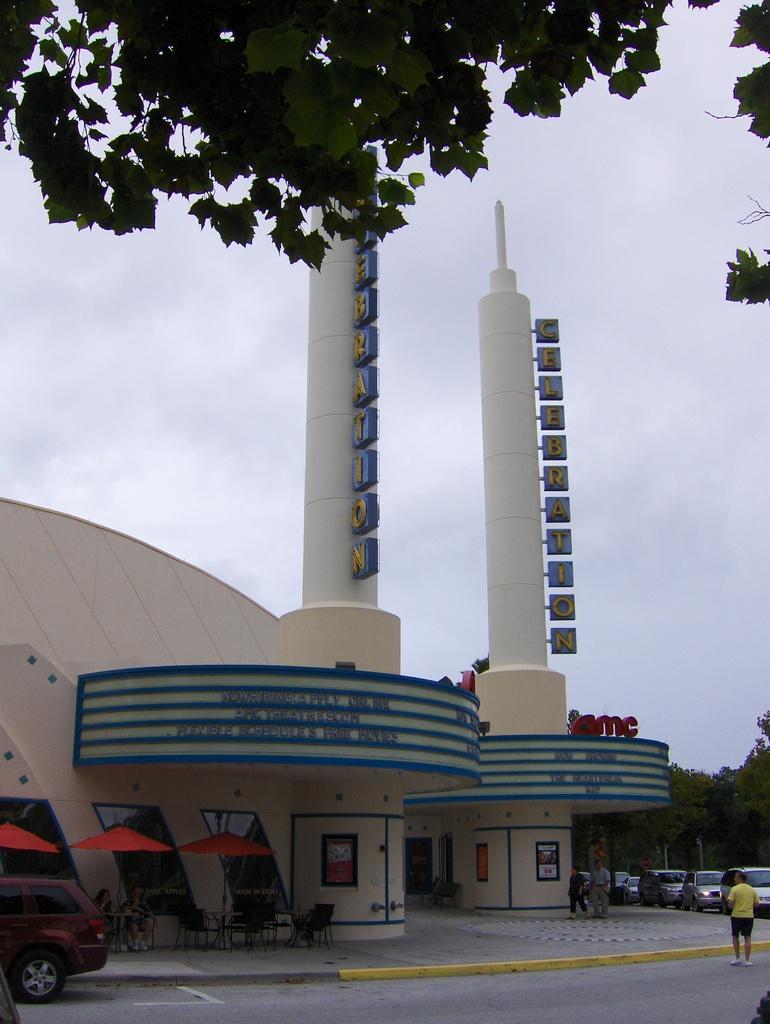Describe this image in one or two sentences. In this picture we can see a building, umbrellas, tables, chairs, trees, vehicles on the road and some people and in the background we can see the sky with clouds. 